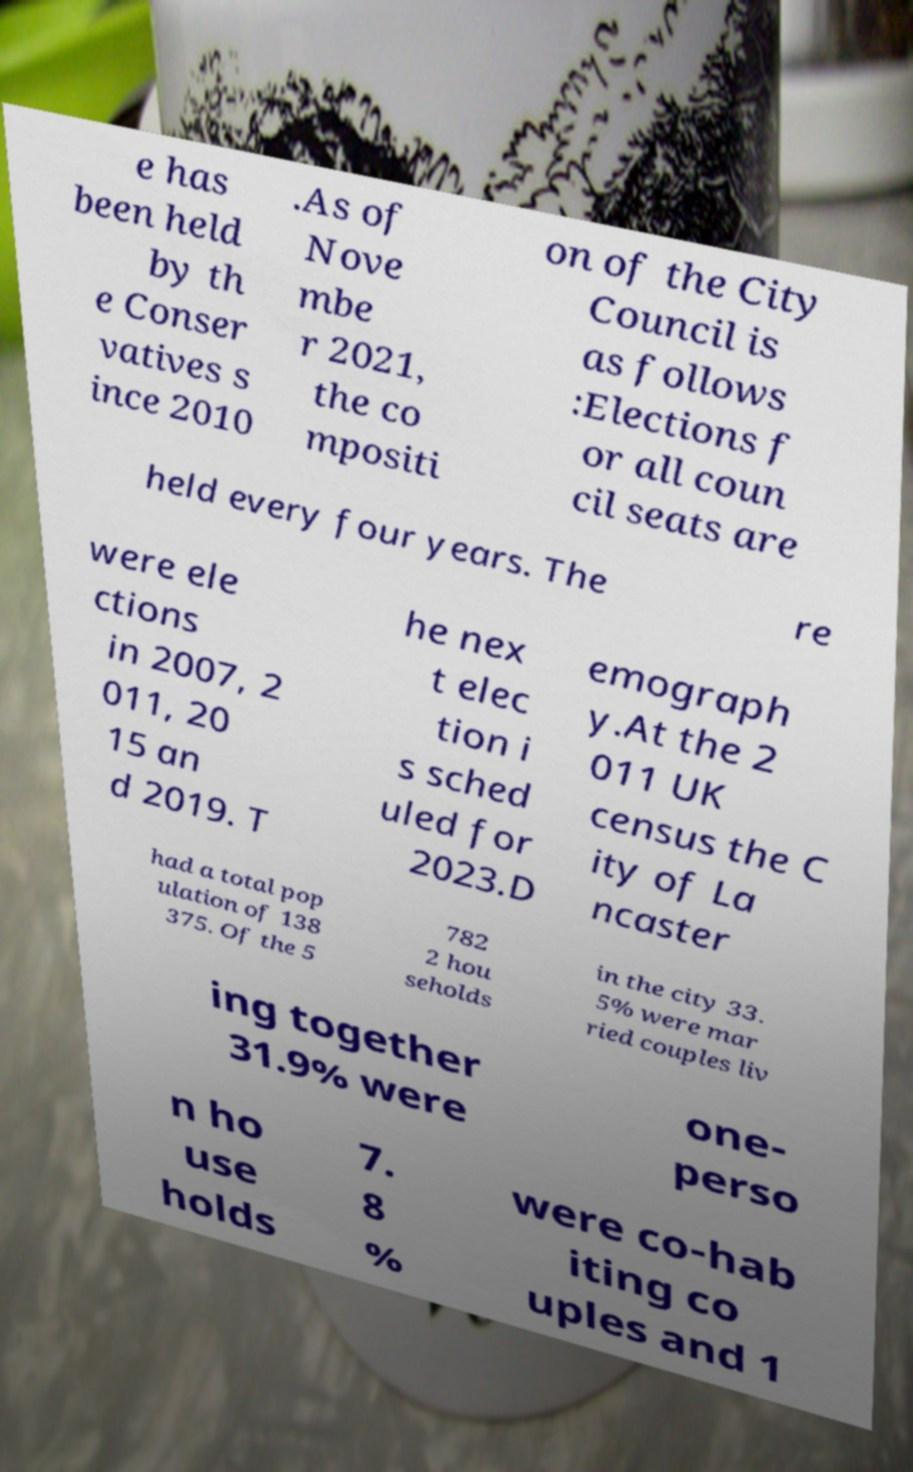There's text embedded in this image that I need extracted. Can you transcribe it verbatim? e has been held by th e Conser vatives s ince 2010 .As of Nove mbe r 2021, the co mpositi on of the City Council is as follows :Elections f or all coun cil seats are held every four years. The re were ele ctions in 2007, 2 011, 20 15 an d 2019. T he nex t elec tion i s sched uled for 2023.D emograph y.At the 2 011 UK census the C ity of La ncaster had a total pop ulation of 138 375. Of the 5 782 2 hou seholds in the city 33. 5% were mar ried couples liv ing together 31.9% were one- perso n ho use holds 7. 8 % were co-hab iting co uples and 1 